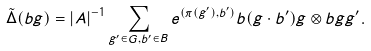Convert formula to latex. <formula><loc_0><loc_0><loc_500><loc_500>\tilde { \Delta } ( b g ) = | A | ^ { - 1 } \sum _ { g ^ { \prime } \in G , b ^ { \prime } \in B } e ^ { ( \pi ( g ^ { \prime } ) , b ^ { \prime } ) } b ( g \cdot b ^ { \prime } ) g \otimes b g g ^ { \prime } .</formula> 